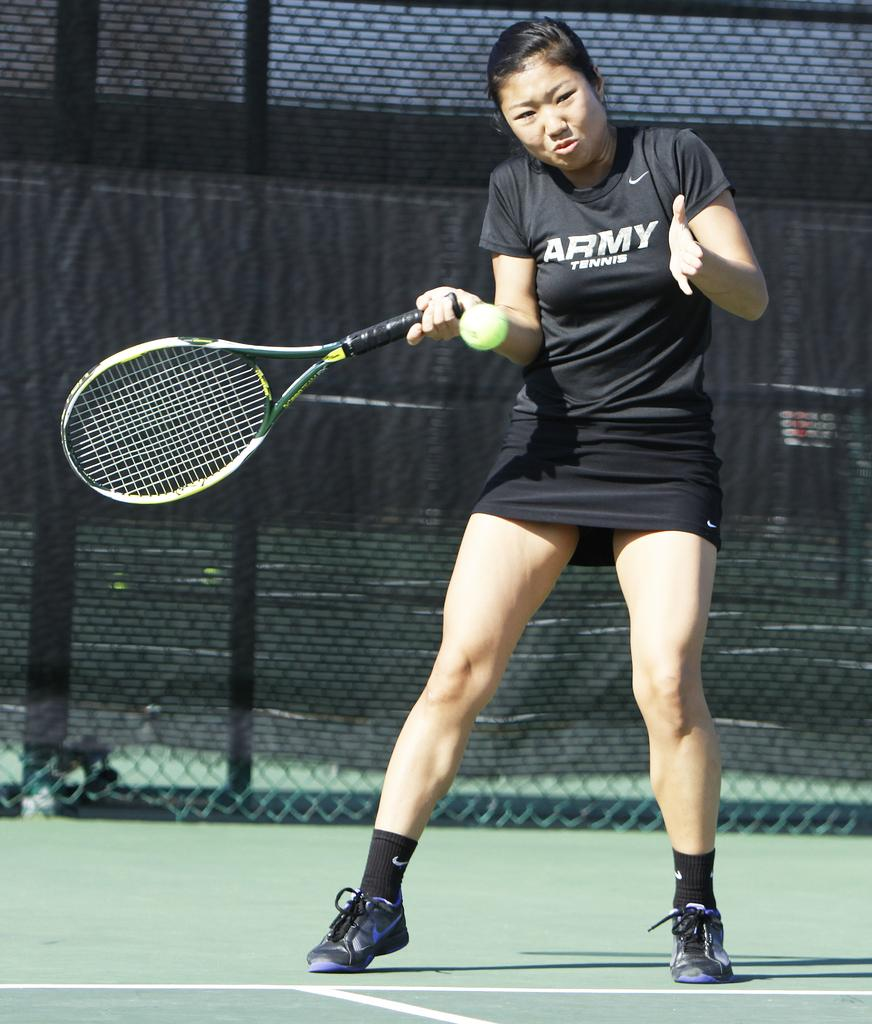What can be seen in the background of the image? There is a net in the background of the image. What color is the net? The net is black in color. Who is present in the image? There is a woman in the image. What is the woman holding? The woman is holding a tennis racket. What else is visible in the image? There is a ball in the image. Where does the image take place? The image depicts a playground. How many cats are playing with the wool in the image? There are no cats or wool present in the image. What is the woman's reaction to the loss in the image? There is no indication of loss or any emotional reaction in the image. 